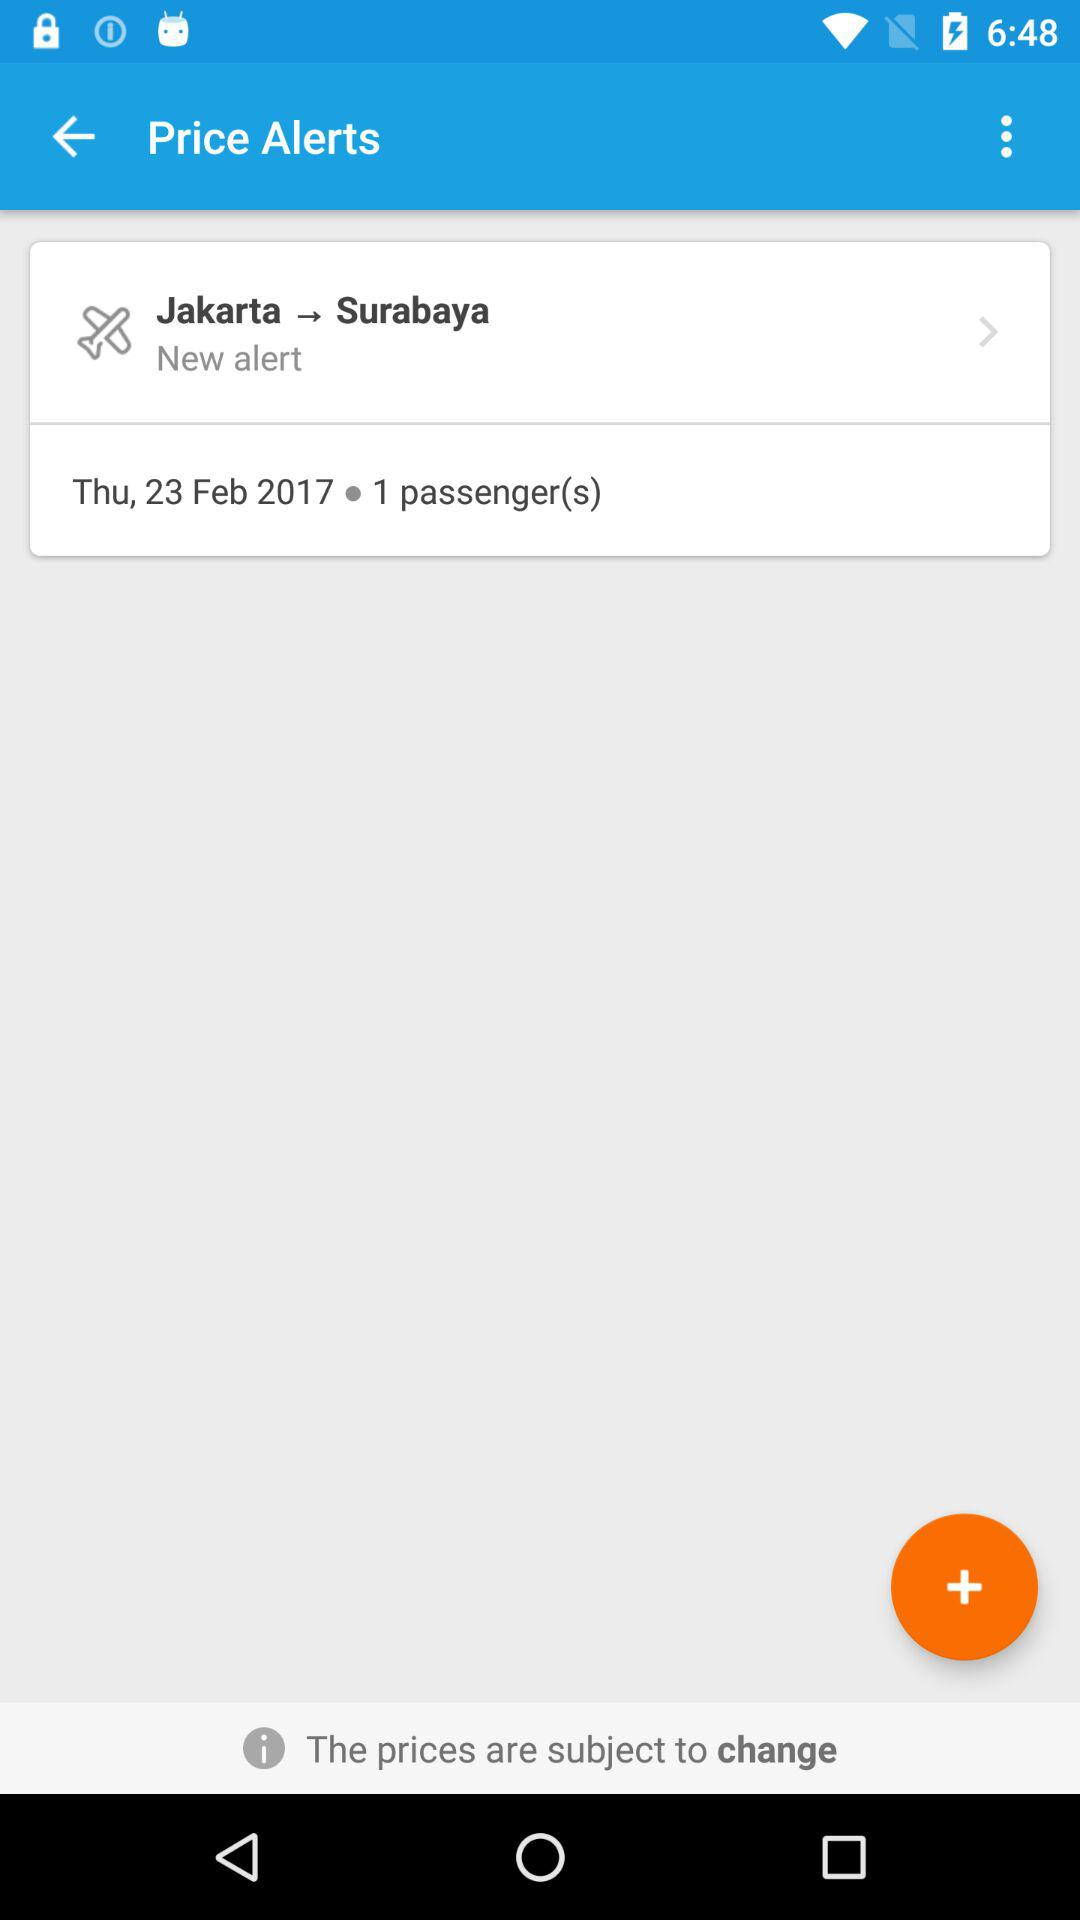Which day has been mentioned for the journey? The day that has been mentioned for the journey is Thursday. 